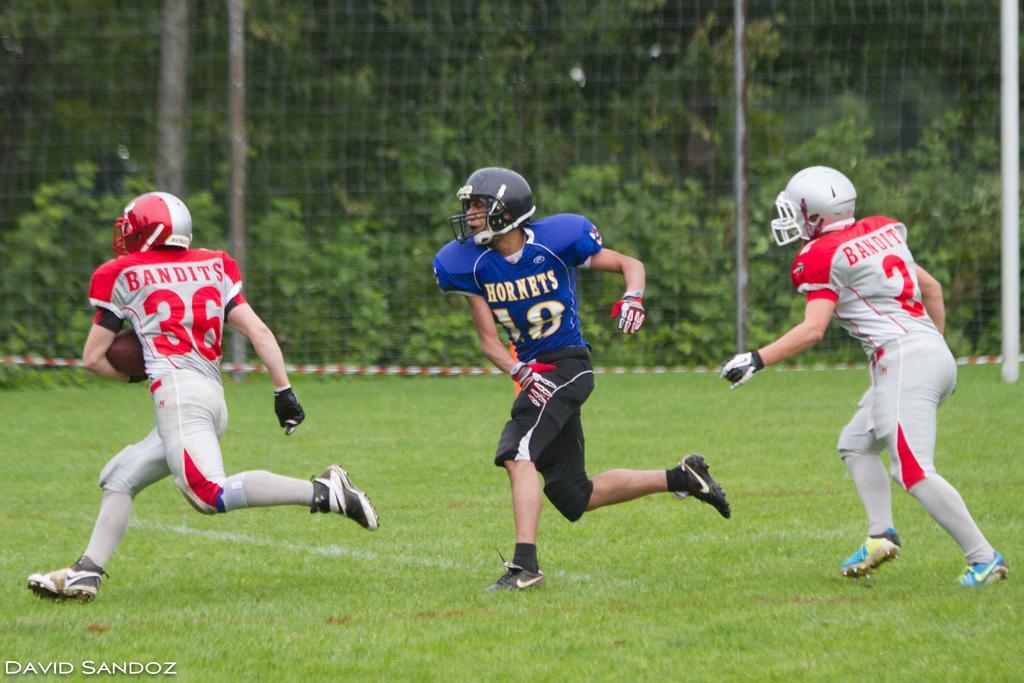Describe this image in one or two sentences. This is the picture where we have three sports people with jerseys and helmets on the field and beside there is a net. 